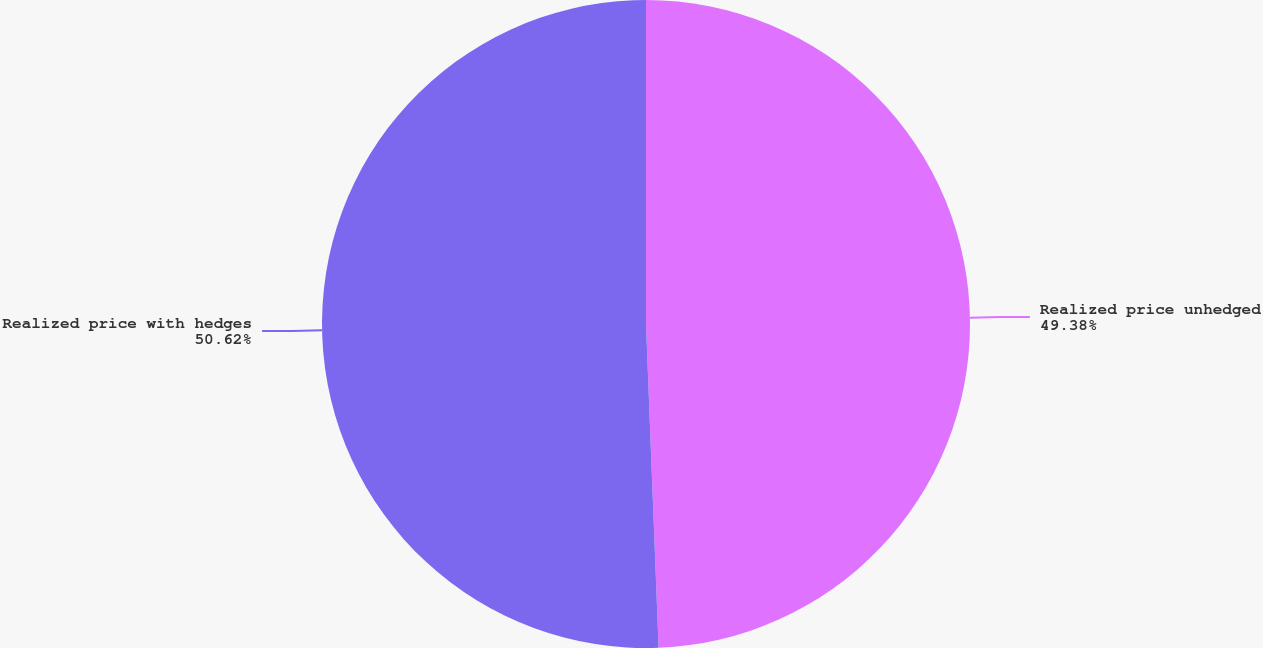<chart> <loc_0><loc_0><loc_500><loc_500><pie_chart><fcel>Realized price unhedged<fcel>Realized price with hedges<nl><fcel>49.38%<fcel>50.62%<nl></chart> 